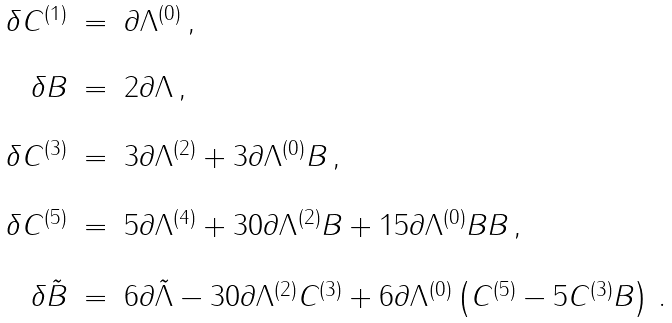<formula> <loc_0><loc_0><loc_500><loc_500>\begin{array} { r c l } \delta C ^ { ( 1 ) } & = & \partial \Lambda ^ { ( 0 ) } \, , \\ & & \\ \delta B & = & 2 \partial \Lambda \, , \\ & & \\ \delta C ^ { ( 3 ) } & = & 3 \partial \Lambda ^ { ( 2 ) } + 3 \partial \Lambda ^ { ( 0 ) } B \, , \\ & & \\ \delta C ^ { ( 5 ) } & = & 5 \partial \Lambda ^ { ( 4 ) } + 3 0 \partial \Lambda ^ { ( 2 ) } B + 1 5 \partial \Lambda ^ { ( 0 ) } B B \, , \\ & & \\ \delta \tilde { B } & = & 6 \partial \tilde { \Lambda } - 3 0 \partial \Lambda ^ { ( 2 ) } C ^ { ( 3 ) } + 6 \partial \Lambda ^ { ( 0 ) } \left ( C ^ { ( 5 ) } - 5 C ^ { ( 3 ) } B \right ) \, . \\ \end{array}</formula> 